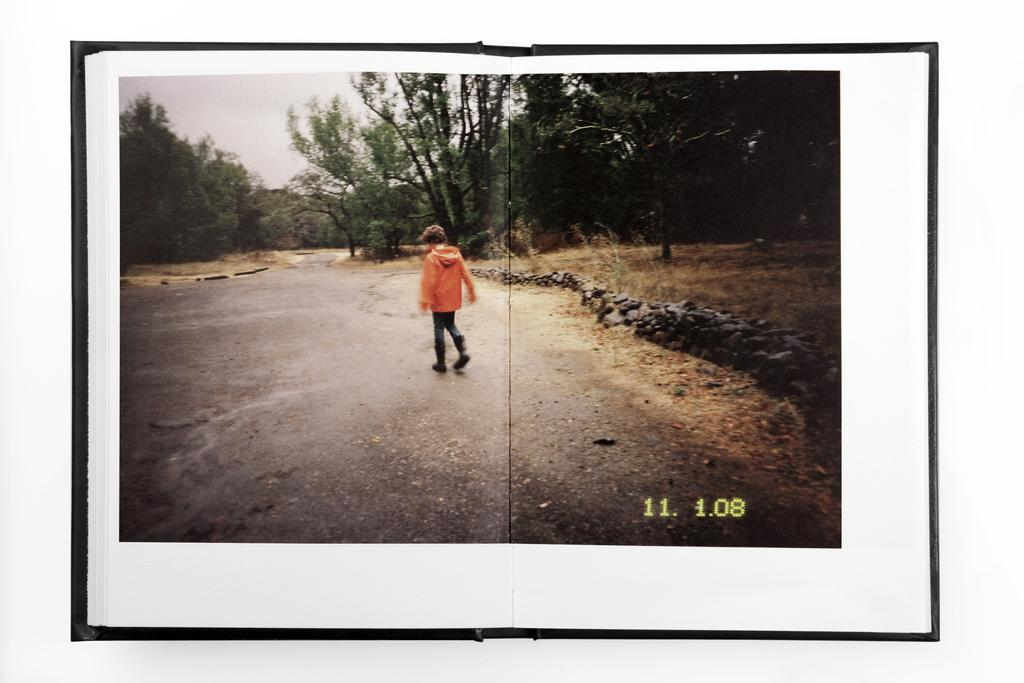What is the main subject of the image? There is a person standing on the road in the image. What can be seen in front of the person? There are trees in front of the person. What is visible in the background of the image? The sky is visible in the image. Can you describe any additional features of the image? The image has a watermark. What type of cakes can be seen being transported by the train in the image? There is no train or cakes present in the image; it features a person standing on the road with trees in front and the sky visible in the background. What language is spoken by the person in the image? The image does not provide any information about the language spoken by the person. 